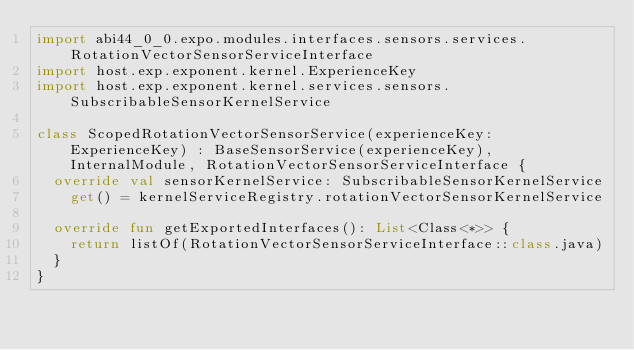<code> <loc_0><loc_0><loc_500><loc_500><_Kotlin_>import abi44_0_0.expo.modules.interfaces.sensors.services.RotationVectorSensorServiceInterface
import host.exp.exponent.kernel.ExperienceKey
import host.exp.exponent.kernel.services.sensors.SubscribableSensorKernelService

class ScopedRotationVectorSensorService(experienceKey: ExperienceKey) : BaseSensorService(experienceKey), InternalModule, RotationVectorSensorServiceInterface {
  override val sensorKernelService: SubscribableSensorKernelService
    get() = kernelServiceRegistry.rotationVectorSensorKernelService

  override fun getExportedInterfaces(): List<Class<*>> {
    return listOf(RotationVectorSensorServiceInterface::class.java)
  }
}
</code> 